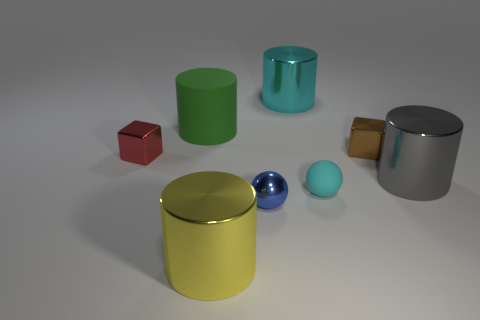What is the size of the gray metal thing that is the same shape as the yellow metallic object?
Your answer should be very brief. Large. Is the tiny metal ball the same color as the rubber cylinder?
Offer a terse response. No. What is the color of the large metal cylinder that is on the right side of the blue thing and in front of the brown metal block?
Ensure brevity in your answer.  Gray. Is the size of the cube that is to the right of the blue metal ball the same as the small blue sphere?
Your answer should be compact. Yes. Is the blue object made of the same material as the block on the left side of the tiny blue shiny thing?
Your answer should be compact. Yes. What number of brown objects are either matte cylinders or shiny balls?
Keep it short and to the point. 0. Are there any cyan metallic objects?
Your answer should be compact. Yes. Are there any small blue metallic spheres right of the large cyan cylinder left of the rubber object that is in front of the small red metallic object?
Offer a terse response. No. Do the red thing and the rubber thing in front of the gray cylinder have the same shape?
Provide a short and direct response. No. There is a matte object in front of the block that is to the right of the tiny block that is on the left side of the large yellow cylinder; what color is it?
Make the answer very short. Cyan. 